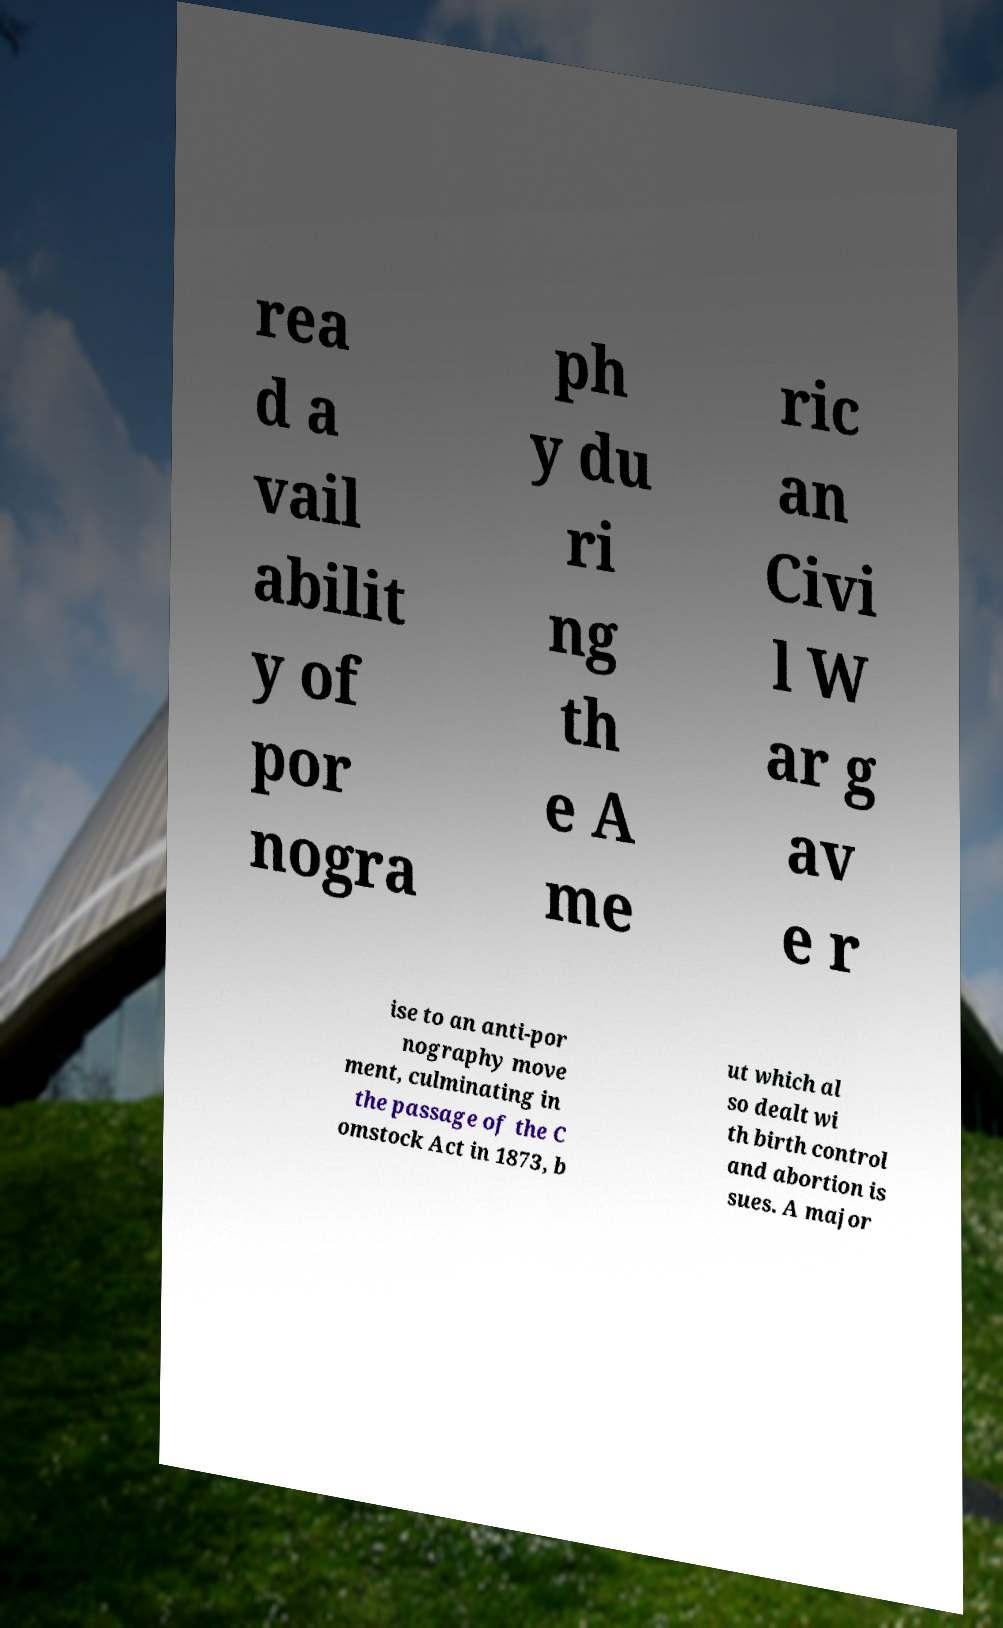Can you read and provide the text displayed in the image?This photo seems to have some interesting text. Can you extract and type it out for me? rea d a vail abilit y of por nogra ph y du ri ng th e A me ric an Civi l W ar g av e r ise to an anti-por nography move ment, culminating in the passage of the C omstock Act in 1873, b ut which al so dealt wi th birth control and abortion is sues. A major 